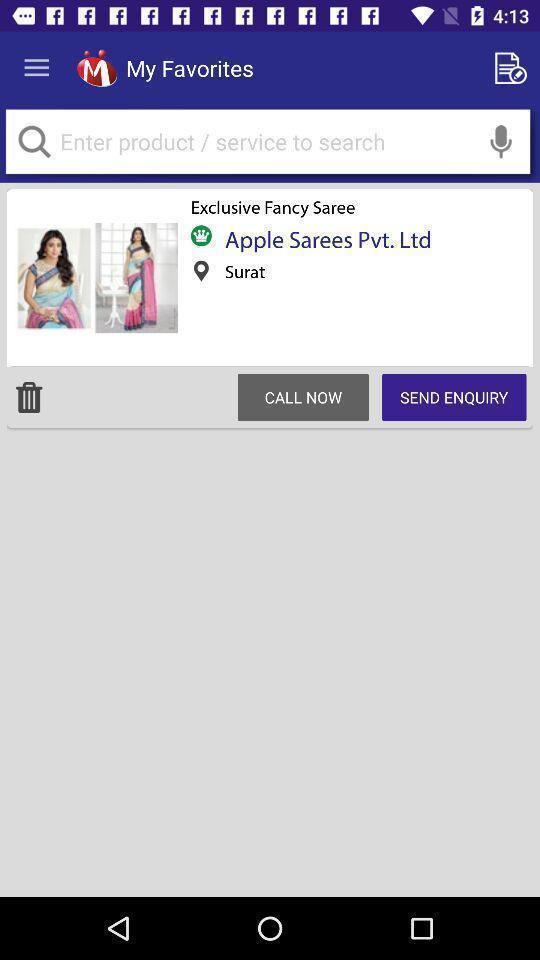Provide a description of this screenshot. Shopping app page contains product search and result. 